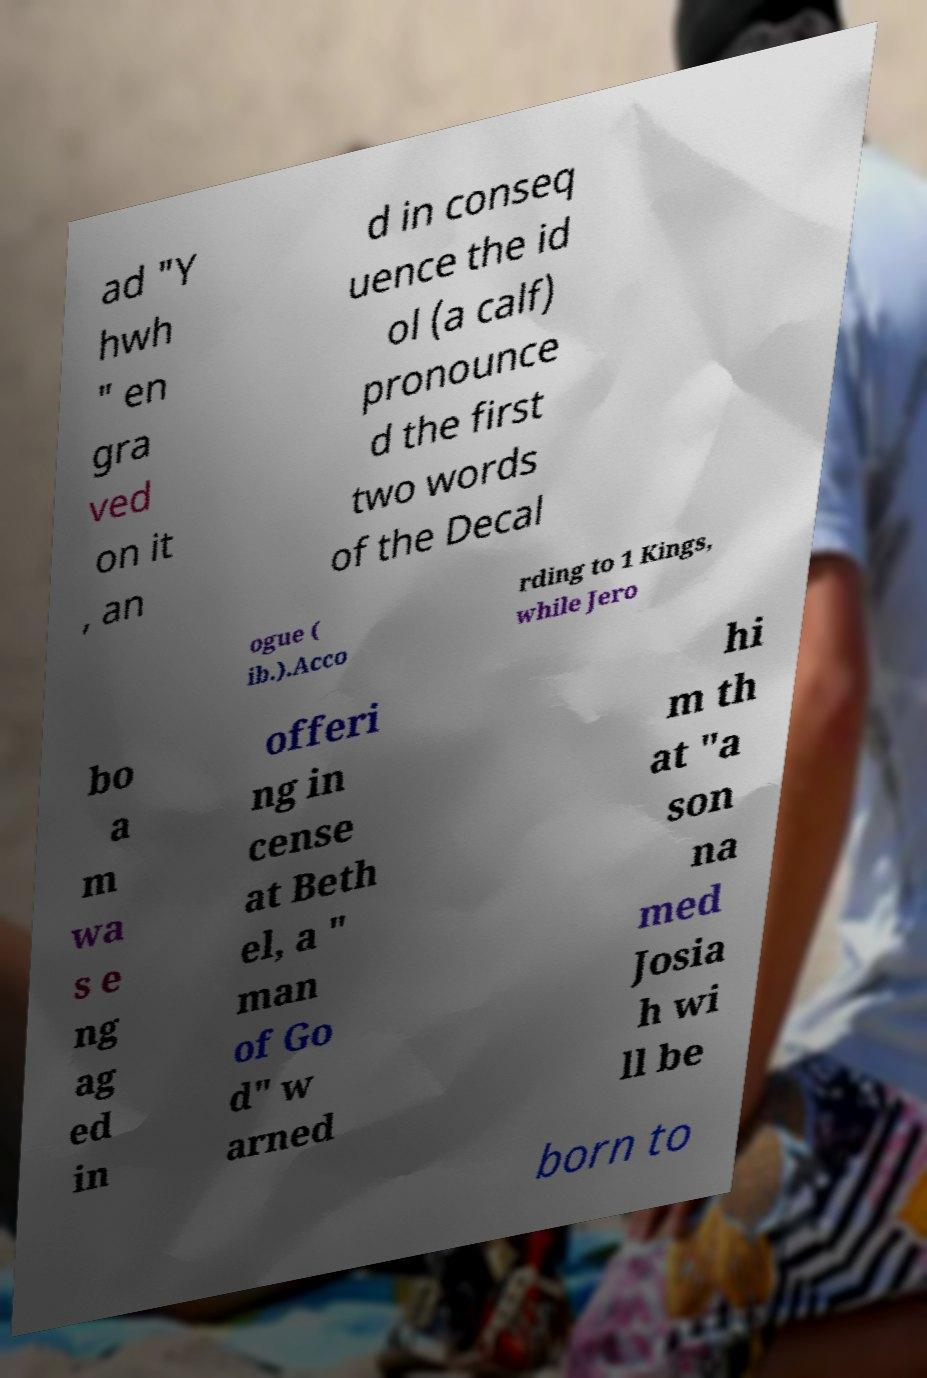There's text embedded in this image that I need extracted. Can you transcribe it verbatim? ad "Y hwh " en gra ved on it , an d in conseq uence the id ol (a calf) pronounce d the first two words of the Decal ogue ( ib.).Acco rding to 1 Kings, while Jero bo a m wa s e ng ag ed in offeri ng in cense at Beth el, a " man of Go d" w arned hi m th at "a son na med Josia h wi ll be born to 